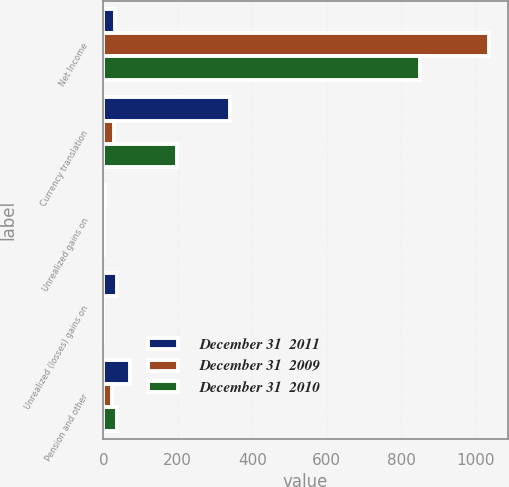<chart> <loc_0><loc_0><loc_500><loc_500><stacked_bar_chart><ecel><fcel>Net Income<fcel>Currency translation<fcel>Unrealized gains on<fcel>Unrealized (losses) gains on<fcel>Pension and other<nl><fcel>December 31  2011<fcel>31.3<fcel>340.8<fcel>3.6<fcel>35.4<fcel>70.5<nl><fcel>December 31  2009<fcel>1035.6<fcel>27.2<fcel>1<fcel>0.2<fcel>22.4<nl><fcel>December 31  2010<fcel>850.3<fcel>198.8<fcel>2.2<fcel>0.2<fcel>36.6<nl></chart> 